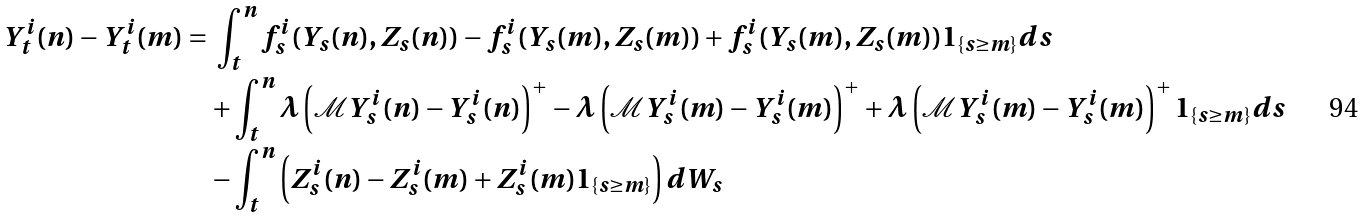<formula> <loc_0><loc_0><loc_500><loc_500>Y _ { t } ^ { i } ( n ) - Y _ { t } ^ { i } ( m ) = & \ \int _ { t } ^ { n } f _ { s } ^ { i } ( Y _ { s } ( n ) , Z _ { s } ( n ) ) - f _ { s } ^ { i } ( Y _ { s } ( m ) , Z _ { s } ( m ) ) + f _ { s } ^ { i } ( Y _ { s } ( m ) , Z _ { s } ( m ) ) 1 _ { \{ s \geq m \} } d s \\ & + \int _ { t } ^ { n } \lambda \left ( \mathcal { M } Y _ { s } ^ { i } ( n ) - Y _ { s } ^ { i } ( n ) \right ) ^ { + } - \lambda \left ( \mathcal { M } Y _ { s } ^ { i } ( m ) - Y _ { s } ^ { i } ( m ) \right ) ^ { + } + \lambda \left ( \mathcal { M } Y _ { s } ^ { i } ( m ) - Y _ { s } ^ { i } ( m ) \right ) ^ { + } 1 _ { \{ s \geq m \} } d s \\ & - \int _ { t } ^ { n } \left ( Z _ { s } ^ { i } ( n ) - Z _ { s } ^ { i } ( m ) + Z _ { s } ^ { i } ( m ) 1 _ { \{ s \geq m \} } \right ) d W _ { s }</formula> 